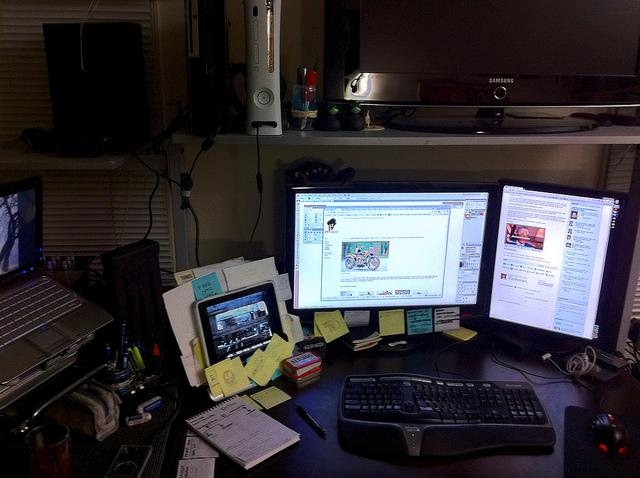What is the item called that has the red lights emanating from it?

Choices:
A) keyboard
B) notepad
C) flashlight
D) mouse mouse 